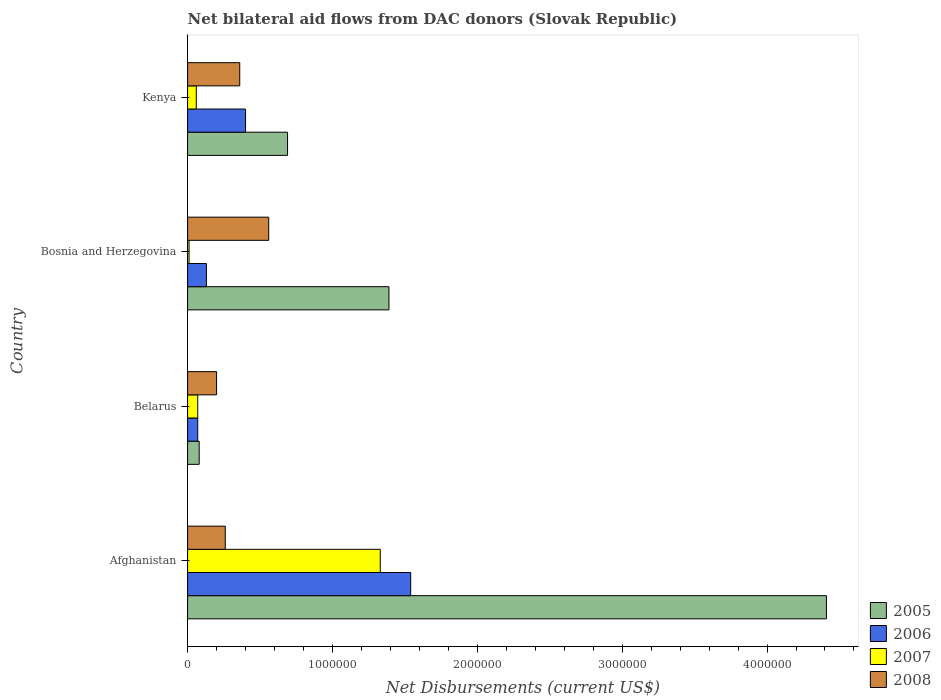How many different coloured bars are there?
Your answer should be very brief. 4. Are the number of bars per tick equal to the number of legend labels?
Offer a terse response. Yes. What is the label of the 3rd group of bars from the top?
Ensure brevity in your answer.  Belarus. In how many cases, is the number of bars for a given country not equal to the number of legend labels?
Your answer should be compact. 0. What is the net bilateral aid flows in 2007 in Afghanistan?
Ensure brevity in your answer.  1.33e+06. Across all countries, what is the maximum net bilateral aid flows in 2006?
Your answer should be compact. 1.54e+06. In which country was the net bilateral aid flows in 2006 maximum?
Your answer should be compact. Afghanistan. In which country was the net bilateral aid flows in 2007 minimum?
Give a very brief answer. Bosnia and Herzegovina. What is the total net bilateral aid flows in 2005 in the graph?
Your response must be concise. 6.57e+06. What is the difference between the net bilateral aid flows in 2007 in Bosnia and Herzegovina and that in Kenya?
Give a very brief answer. -5.00e+04. What is the difference between the net bilateral aid flows in 2008 in Belarus and the net bilateral aid flows in 2006 in Afghanistan?
Provide a short and direct response. -1.34e+06. What is the average net bilateral aid flows in 2008 per country?
Offer a very short reply. 3.45e+05. What is the difference between the net bilateral aid flows in 2005 and net bilateral aid flows in 2007 in Kenya?
Offer a very short reply. 6.30e+05. What is the ratio of the net bilateral aid flows in 2006 in Afghanistan to that in Belarus?
Provide a succinct answer. 22. What is the difference between the highest and the second highest net bilateral aid flows in 2006?
Offer a very short reply. 1.14e+06. What is the difference between the highest and the lowest net bilateral aid flows in 2005?
Your answer should be compact. 4.33e+06. Is it the case that in every country, the sum of the net bilateral aid flows in 2007 and net bilateral aid flows in 2005 is greater than the sum of net bilateral aid flows in 2008 and net bilateral aid flows in 2006?
Make the answer very short. No. What does the 3rd bar from the top in Kenya represents?
Give a very brief answer. 2006. How many bars are there?
Your answer should be very brief. 16. Are all the bars in the graph horizontal?
Your response must be concise. Yes. How many countries are there in the graph?
Make the answer very short. 4. Are the values on the major ticks of X-axis written in scientific E-notation?
Your response must be concise. No. Does the graph contain grids?
Provide a succinct answer. No. How many legend labels are there?
Provide a succinct answer. 4. What is the title of the graph?
Provide a short and direct response. Net bilateral aid flows from DAC donors (Slovak Republic). What is the label or title of the X-axis?
Provide a short and direct response. Net Disbursements (current US$). What is the Net Disbursements (current US$) in 2005 in Afghanistan?
Offer a terse response. 4.41e+06. What is the Net Disbursements (current US$) of 2006 in Afghanistan?
Ensure brevity in your answer.  1.54e+06. What is the Net Disbursements (current US$) in 2007 in Afghanistan?
Provide a short and direct response. 1.33e+06. What is the Net Disbursements (current US$) of 2005 in Belarus?
Ensure brevity in your answer.  8.00e+04. What is the Net Disbursements (current US$) of 2008 in Belarus?
Make the answer very short. 2.00e+05. What is the Net Disbursements (current US$) of 2005 in Bosnia and Herzegovina?
Give a very brief answer. 1.39e+06. What is the Net Disbursements (current US$) in 2007 in Bosnia and Herzegovina?
Offer a terse response. 10000. What is the Net Disbursements (current US$) in 2008 in Bosnia and Herzegovina?
Offer a terse response. 5.60e+05. What is the Net Disbursements (current US$) of 2005 in Kenya?
Ensure brevity in your answer.  6.90e+05. Across all countries, what is the maximum Net Disbursements (current US$) in 2005?
Ensure brevity in your answer.  4.41e+06. Across all countries, what is the maximum Net Disbursements (current US$) of 2006?
Give a very brief answer. 1.54e+06. Across all countries, what is the maximum Net Disbursements (current US$) of 2007?
Offer a very short reply. 1.33e+06. Across all countries, what is the maximum Net Disbursements (current US$) of 2008?
Your response must be concise. 5.60e+05. What is the total Net Disbursements (current US$) in 2005 in the graph?
Your response must be concise. 6.57e+06. What is the total Net Disbursements (current US$) of 2006 in the graph?
Keep it short and to the point. 2.14e+06. What is the total Net Disbursements (current US$) in 2007 in the graph?
Give a very brief answer. 1.47e+06. What is the total Net Disbursements (current US$) in 2008 in the graph?
Keep it short and to the point. 1.38e+06. What is the difference between the Net Disbursements (current US$) in 2005 in Afghanistan and that in Belarus?
Make the answer very short. 4.33e+06. What is the difference between the Net Disbursements (current US$) of 2006 in Afghanistan and that in Belarus?
Make the answer very short. 1.47e+06. What is the difference between the Net Disbursements (current US$) in 2007 in Afghanistan and that in Belarus?
Provide a succinct answer. 1.26e+06. What is the difference between the Net Disbursements (current US$) in 2005 in Afghanistan and that in Bosnia and Herzegovina?
Your answer should be very brief. 3.02e+06. What is the difference between the Net Disbursements (current US$) in 2006 in Afghanistan and that in Bosnia and Herzegovina?
Your answer should be compact. 1.41e+06. What is the difference between the Net Disbursements (current US$) in 2007 in Afghanistan and that in Bosnia and Herzegovina?
Your answer should be very brief. 1.32e+06. What is the difference between the Net Disbursements (current US$) in 2005 in Afghanistan and that in Kenya?
Your answer should be very brief. 3.72e+06. What is the difference between the Net Disbursements (current US$) in 2006 in Afghanistan and that in Kenya?
Provide a succinct answer. 1.14e+06. What is the difference between the Net Disbursements (current US$) in 2007 in Afghanistan and that in Kenya?
Make the answer very short. 1.27e+06. What is the difference between the Net Disbursements (current US$) in 2005 in Belarus and that in Bosnia and Herzegovina?
Ensure brevity in your answer.  -1.31e+06. What is the difference between the Net Disbursements (current US$) of 2006 in Belarus and that in Bosnia and Herzegovina?
Offer a terse response. -6.00e+04. What is the difference between the Net Disbursements (current US$) of 2008 in Belarus and that in Bosnia and Herzegovina?
Your response must be concise. -3.60e+05. What is the difference between the Net Disbursements (current US$) of 2005 in Belarus and that in Kenya?
Provide a short and direct response. -6.10e+05. What is the difference between the Net Disbursements (current US$) of 2006 in Belarus and that in Kenya?
Make the answer very short. -3.30e+05. What is the difference between the Net Disbursements (current US$) of 2007 in Belarus and that in Kenya?
Your answer should be compact. 10000. What is the difference between the Net Disbursements (current US$) in 2008 in Belarus and that in Kenya?
Offer a terse response. -1.60e+05. What is the difference between the Net Disbursements (current US$) in 2005 in Bosnia and Herzegovina and that in Kenya?
Provide a succinct answer. 7.00e+05. What is the difference between the Net Disbursements (current US$) of 2006 in Bosnia and Herzegovina and that in Kenya?
Provide a short and direct response. -2.70e+05. What is the difference between the Net Disbursements (current US$) of 2007 in Bosnia and Herzegovina and that in Kenya?
Offer a very short reply. -5.00e+04. What is the difference between the Net Disbursements (current US$) of 2005 in Afghanistan and the Net Disbursements (current US$) of 2006 in Belarus?
Your response must be concise. 4.34e+06. What is the difference between the Net Disbursements (current US$) of 2005 in Afghanistan and the Net Disbursements (current US$) of 2007 in Belarus?
Give a very brief answer. 4.34e+06. What is the difference between the Net Disbursements (current US$) in 2005 in Afghanistan and the Net Disbursements (current US$) in 2008 in Belarus?
Offer a terse response. 4.21e+06. What is the difference between the Net Disbursements (current US$) in 2006 in Afghanistan and the Net Disbursements (current US$) in 2007 in Belarus?
Offer a very short reply. 1.47e+06. What is the difference between the Net Disbursements (current US$) of 2006 in Afghanistan and the Net Disbursements (current US$) of 2008 in Belarus?
Your answer should be very brief. 1.34e+06. What is the difference between the Net Disbursements (current US$) in 2007 in Afghanistan and the Net Disbursements (current US$) in 2008 in Belarus?
Your answer should be compact. 1.13e+06. What is the difference between the Net Disbursements (current US$) of 2005 in Afghanistan and the Net Disbursements (current US$) of 2006 in Bosnia and Herzegovina?
Offer a terse response. 4.28e+06. What is the difference between the Net Disbursements (current US$) in 2005 in Afghanistan and the Net Disbursements (current US$) in 2007 in Bosnia and Herzegovina?
Keep it short and to the point. 4.40e+06. What is the difference between the Net Disbursements (current US$) in 2005 in Afghanistan and the Net Disbursements (current US$) in 2008 in Bosnia and Herzegovina?
Your answer should be very brief. 3.85e+06. What is the difference between the Net Disbursements (current US$) of 2006 in Afghanistan and the Net Disbursements (current US$) of 2007 in Bosnia and Herzegovina?
Make the answer very short. 1.53e+06. What is the difference between the Net Disbursements (current US$) of 2006 in Afghanistan and the Net Disbursements (current US$) of 2008 in Bosnia and Herzegovina?
Make the answer very short. 9.80e+05. What is the difference between the Net Disbursements (current US$) of 2007 in Afghanistan and the Net Disbursements (current US$) of 2008 in Bosnia and Herzegovina?
Offer a very short reply. 7.70e+05. What is the difference between the Net Disbursements (current US$) of 2005 in Afghanistan and the Net Disbursements (current US$) of 2006 in Kenya?
Ensure brevity in your answer.  4.01e+06. What is the difference between the Net Disbursements (current US$) of 2005 in Afghanistan and the Net Disbursements (current US$) of 2007 in Kenya?
Give a very brief answer. 4.35e+06. What is the difference between the Net Disbursements (current US$) in 2005 in Afghanistan and the Net Disbursements (current US$) in 2008 in Kenya?
Provide a succinct answer. 4.05e+06. What is the difference between the Net Disbursements (current US$) in 2006 in Afghanistan and the Net Disbursements (current US$) in 2007 in Kenya?
Ensure brevity in your answer.  1.48e+06. What is the difference between the Net Disbursements (current US$) in 2006 in Afghanistan and the Net Disbursements (current US$) in 2008 in Kenya?
Give a very brief answer. 1.18e+06. What is the difference between the Net Disbursements (current US$) in 2007 in Afghanistan and the Net Disbursements (current US$) in 2008 in Kenya?
Offer a very short reply. 9.70e+05. What is the difference between the Net Disbursements (current US$) in 2005 in Belarus and the Net Disbursements (current US$) in 2007 in Bosnia and Herzegovina?
Make the answer very short. 7.00e+04. What is the difference between the Net Disbursements (current US$) in 2005 in Belarus and the Net Disbursements (current US$) in 2008 in Bosnia and Herzegovina?
Give a very brief answer. -4.80e+05. What is the difference between the Net Disbursements (current US$) in 2006 in Belarus and the Net Disbursements (current US$) in 2008 in Bosnia and Herzegovina?
Your answer should be compact. -4.90e+05. What is the difference between the Net Disbursements (current US$) of 2007 in Belarus and the Net Disbursements (current US$) of 2008 in Bosnia and Herzegovina?
Offer a very short reply. -4.90e+05. What is the difference between the Net Disbursements (current US$) of 2005 in Belarus and the Net Disbursements (current US$) of 2006 in Kenya?
Offer a very short reply. -3.20e+05. What is the difference between the Net Disbursements (current US$) in 2005 in Belarus and the Net Disbursements (current US$) in 2007 in Kenya?
Provide a succinct answer. 2.00e+04. What is the difference between the Net Disbursements (current US$) in 2005 in Belarus and the Net Disbursements (current US$) in 2008 in Kenya?
Offer a terse response. -2.80e+05. What is the difference between the Net Disbursements (current US$) of 2006 in Belarus and the Net Disbursements (current US$) of 2008 in Kenya?
Make the answer very short. -2.90e+05. What is the difference between the Net Disbursements (current US$) of 2005 in Bosnia and Herzegovina and the Net Disbursements (current US$) of 2006 in Kenya?
Your answer should be very brief. 9.90e+05. What is the difference between the Net Disbursements (current US$) in 2005 in Bosnia and Herzegovina and the Net Disbursements (current US$) in 2007 in Kenya?
Provide a short and direct response. 1.33e+06. What is the difference between the Net Disbursements (current US$) of 2005 in Bosnia and Herzegovina and the Net Disbursements (current US$) of 2008 in Kenya?
Offer a very short reply. 1.03e+06. What is the difference between the Net Disbursements (current US$) in 2006 in Bosnia and Herzegovina and the Net Disbursements (current US$) in 2008 in Kenya?
Give a very brief answer. -2.30e+05. What is the difference between the Net Disbursements (current US$) in 2007 in Bosnia and Herzegovina and the Net Disbursements (current US$) in 2008 in Kenya?
Provide a succinct answer. -3.50e+05. What is the average Net Disbursements (current US$) in 2005 per country?
Your answer should be very brief. 1.64e+06. What is the average Net Disbursements (current US$) in 2006 per country?
Ensure brevity in your answer.  5.35e+05. What is the average Net Disbursements (current US$) of 2007 per country?
Give a very brief answer. 3.68e+05. What is the average Net Disbursements (current US$) of 2008 per country?
Offer a terse response. 3.45e+05. What is the difference between the Net Disbursements (current US$) of 2005 and Net Disbursements (current US$) of 2006 in Afghanistan?
Ensure brevity in your answer.  2.87e+06. What is the difference between the Net Disbursements (current US$) of 2005 and Net Disbursements (current US$) of 2007 in Afghanistan?
Your answer should be compact. 3.08e+06. What is the difference between the Net Disbursements (current US$) in 2005 and Net Disbursements (current US$) in 2008 in Afghanistan?
Ensure brevity in your answer.  4.15e+06. What is the difference between the Net Disbursements (current US$) in 2006 and Net Disbursements (current US$) in 2007 in Afghanistan?
Provide a succinct answer. 2.10e+05. What is the difference between the Net Disbursements (current US$) in 2006 and Net Disbursements (current US$) in 2008 in Afghanistan?
Offer a terse response. 1.28e+06. What is the difference between the Net Disbursements (current US$) in 2007 and Net Disbursements (current US$) in 2008 in Afghanistan?
Offer a terse response. 1.07e+06. What is the difference between the Net Disbursements (current US$) of 2005 and Net Disbursements (current US$) of 2006 in Belarus?
Keep it short and to the point. 10000. What is the difference between the Net Disbursements (current US$) in 2005 and Net Disbursements (current US$) in 2006 in Bosnia and Herzegovina?
Offer a terse response. 1.26e+06. What is the difference between the Net Disbursements (current US$) of 2005 and Net Disbursements (current US$) of 2007 in Bosnia and Herzegovina?
Provide a short and direct response. 1.38e+06. What is the difference between the Net Disbursements (current US$) of 2005 and Net Disbursements (current US$) of 2008 in Bosnia and Herzegovina?
Give a very brief answer. 8.30e+05. What is the difference between the Net Disbursements (current US$) in 2006 and Net Disbursements (current US$) in 2007 in Bosnia and Herzegovina?
Provide a short and direct response. 1.20e+05. What is the difference between the Net Disbursements (current US$) of 2006 and Net Disbursements (current US$) of 2008 in Bosnia and Herzegovina?
Make the answer very short. -4.30e+05. What is the difference between the Net Disbursements (current US$) of 2007 and Net Disbursements (current US$) of 2008 in Bosnia and Herzegovina?
Provide a succinct answer. -5.50e+05. What is the difference between the Net Disbursements (current US$) in 2005 and Net Disbursements (current US$) in 2007 in Kenya?
Your response must be concise. 6.30e+05. What is the difference between the Net Disbursements (current US$) of 2005 and Net Disbursements (current US$) of 2008 in Kenya?
Give a very brief answer. 3.30e+05. What is the difference between the Net Disbursements (current US$) in 2006 and Net Disbursements (current US$) in 2007 in Kenya?
Provide a short and direct response. 3.40e+05. What is the difference between the Net Disbursements (current US$) in 2006 and Net Disbursements (current US$) in 2008 in Kenya?
Make the answer very short. 4.00e+04. What is the ratio of the Net Disbursements (current US$) of 2005 in Afghanistan to that in Belarus?
Keep it short and to the point. 55.12. What is the ratio of the Net Disbursements (current US$) in 2006 in Afghanistan to that in Belarus?
Offer a terse response. 22. What is the ratio of the Net Disbursements (current US$) of 2007 in Afghanistan to that in Belarus?
Keep it short and to the point. 19. What is the ratio of the Net Disbursements (current US$) of 2008 in Afghanistan to that in Belarus?
Provide a short and direct response. 1.3. What is the ratio of the Net Disbursements (current US$) in 2005 in Afghanistan to that in Bosnia and Herzegovina?
Give a very brief answer. 3.17. What is the ratio of the Net Disbursements (current US$) of 2006 in Afghanistan to that in Bosnia and Herzegovina?
Provide a short and direct response. 11.85. What is the ratio of the Net Disbursements (current US$) in 2007 in Afghanistan to that in Bosnia and Herzegovina?
Provide a short and direct response. 133. What is the ratio of the Net Disbursements (current US$) of 2008 in Afghanistan to that in Bosnia and Herzegovina?
Offer a very short reply. 0.46. What is the ratio of the Net Disbursements (current US$) of 2005 in Afghanistan to that in Kenya?
Your response must be concise. 6.39. What is the ratio of the Net Disbursements (current US$) of 2006 in Afghanistan to that in Kenya?
Provide a short and direct response. 3.85. What is the ratio of the Net Disbursements (current US$) of 2007 in Afghanistan to that in Kenya?
Your answer should be compact. 22.17. What is the ratio of the Net Disbursements (current US$) in 2008 in Afghanistan to that in Kenya?
Ensure brevity in your answer.  0.72. What is the ratio of the Net Disbursements (current US$) of 2005 in Belarus to that in Bosnia and Herzegovina?
Ensure brevity in your answer.  0.06. What is the ratio of the Net Disbursements (current US$) of 2006 in Belarus to that in Bosnia and Herzegovina?
Offer a very short reply. 0.54. What is the ratio of the Net Disbursements (current US$) in 2008 in Belarus to that in Bosnia and Herzegovina?
Offer a very short reply. 0.36. What is the ratio of the Net Disbursements (current US$) in 2005 in Belarus to that in Kenya?
Your response must be concise. 0.12. What is the ratio of the Net Disbursements (current US$) of 2006 in Belarus to that in Kenya?
Keep it short and to the point. 0.17. What is the ratio of the Net Disbursements (current US$) of 2007 in Belarus to that in Kenya?
Keep it short and to the point. 1.17. What is the ratio of the Net Disbursements (current US$) in 2008 in Belarus to that in Kenya?
Give a very brief answer. 0.56. What is the ratio of the Net Disbursements (current US$) of 2005 in Bosnia and Herzegovina to that in Kenya?
Your response must be concise. 2.01. What is the ratio of the Net Disbursements (current US$) in 2006 in Bosnia and Herzegovina to that in Kenya?
Provide a succinct answer. 0.33. What is the ratio of the Net Disbursements (current US$) of 2007 in Bosnia and Herzegovina to that in Kenya?
Your answer should be very brief. 0.17. What is the ratio of the Net Disbursements (current US$) in 2008 in Bosnia and Herzegovina to that in Kenya?
Provide a succinct answer. 1.56. What is the difference between the highest and the second highest Net Disbursements (current US$) in 2005?
Provide a short and direct response. 3.02e+06. What is the difference between the highest and the second highest Net Disbursements (current US$) of 2006?
Provide a short and direct response. 1.14e+06. What is the difference between the highest and the second highest Net Disbursements (current US$) in 2007?
Make the answer very short. 1.26e+06. What is the difference between the highest and the second highest Net Disbursements (current US$) in 2008?
Ensure brevity in your answer.  2.00e+05. What is the difference between the highest and the lowest Net Disbursements (current US$) of 2005?
Offer a very short reply. 4.33e+06. What is the difference between the highest and the lowest Net Disbursements (current US$) in 2006?
Make the answer very short. 1.47e+06. What is the difference between the highest and the lowest Net Disbursements (current US$) of 2007?
Provide a succinct answer. 1.32e+06. What is the difference between the highest and the lowest Net Disbursements (current US$) in 2008?
Ensure brevity in your answer.  3.60e+05. 